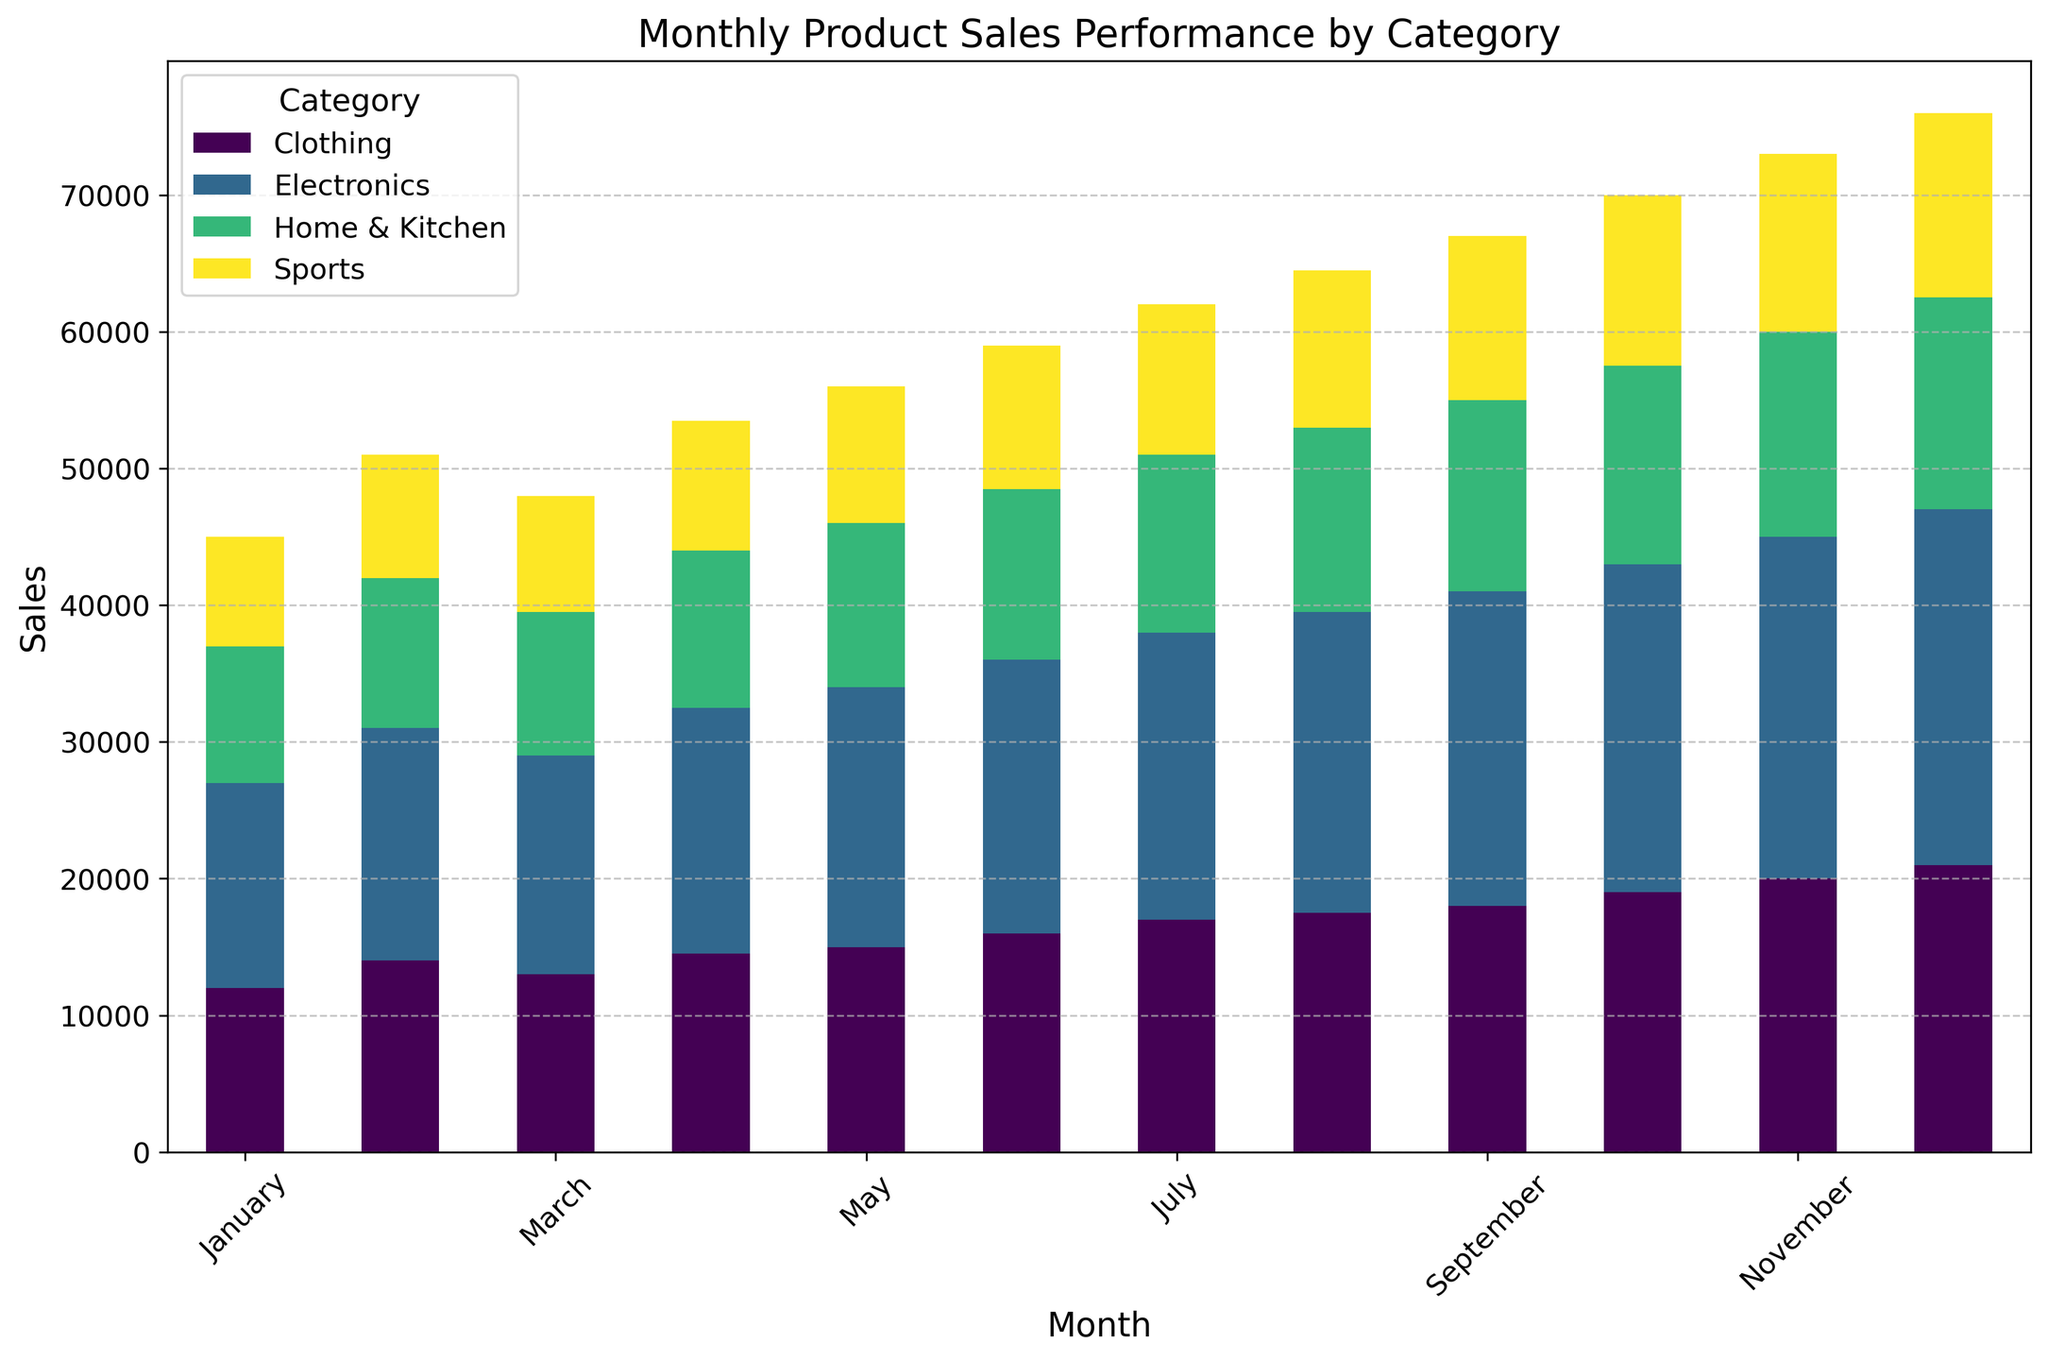What month had the highest total sales for Electronics? To answer this, look at the bar that represents Electronics for each month and identify the tallest bar. The bar for December is the tallest, meaning December had the highest sales for Electronics.
Answer: December Which category had the lowest sales in March? Examine the bars for each category in March and identify the shortest one. The Sports category has the shortest bar in March.
Answer: Sports What is the total sales for Home & Kitchen in the first quarter (January to March)? Sum up the sales for Home & Kitchen in January, February, and March: 10000 + 11000 + 10500 = 31500.
Answer: 31500 How did Clothing sales in July compare to August? Compare the height of the Clothing bars in July and August. The bar for August is slightly taller than the one for July.
Answer: Higher in August Did the Sports category see a consistent increase in sales throughout the year? To determine this, look at the height of the bars for the Sports category in each month and check for a consistent increase. The Sales in Sports consistently increase every month from January to December.
Answer: Yes What month had the greatest total sales across all categories? Sum the heights of the bars for each month and identify the highest total. December has the highest combined bar height, indicating the greatest total sales.
Answer: December Which month had the smallest difference in sales between Electronics and Home & Kitchen? Calculate the difference in bar heights for Electronics and Home & Kitchen in each month. The smallest difference is in January (15000 - 10000 = 5000).
Answer: January What is the proportion of Clothing sales to total sales in November? First, sum the sales of all categories for November: 25000 (Electronics) + 20000 (Clothing) + 15000 (Home & Kitchen) + 13000 (Sports) = 73000. Then, the proportion of Clothing sales to the total sales is 20000 / 73000 ≈ 0.273.
Answer: ~0.27 or 27% Which category had the highest average monthly sales? Calculate the average for each category by summing their monthly sales and dividing by 12. Electronics: (15000+17000+...+26000)/12, Clothing: (12000+14000+...+21000)/12, Home & Kitchen: (10000+11000+...+15500)/12, Sports: (8000+9000+...+13500)/12. Electronics has the highest average.
Answer: Electronics What is the cumulative increase in sales for Electronics from January to December? Calculate the increase in sales for each month compared to the previous month and sum these values. (17000-15000) + (16000-17000) + (18000-16000) + (19000-18000) + (20000-19000) + (21000-20000) + (22000-21000) + (23000-22000) + (24000-23000) + (25000-24000) + (26000-25000) = 11000.
Answer: 11000 